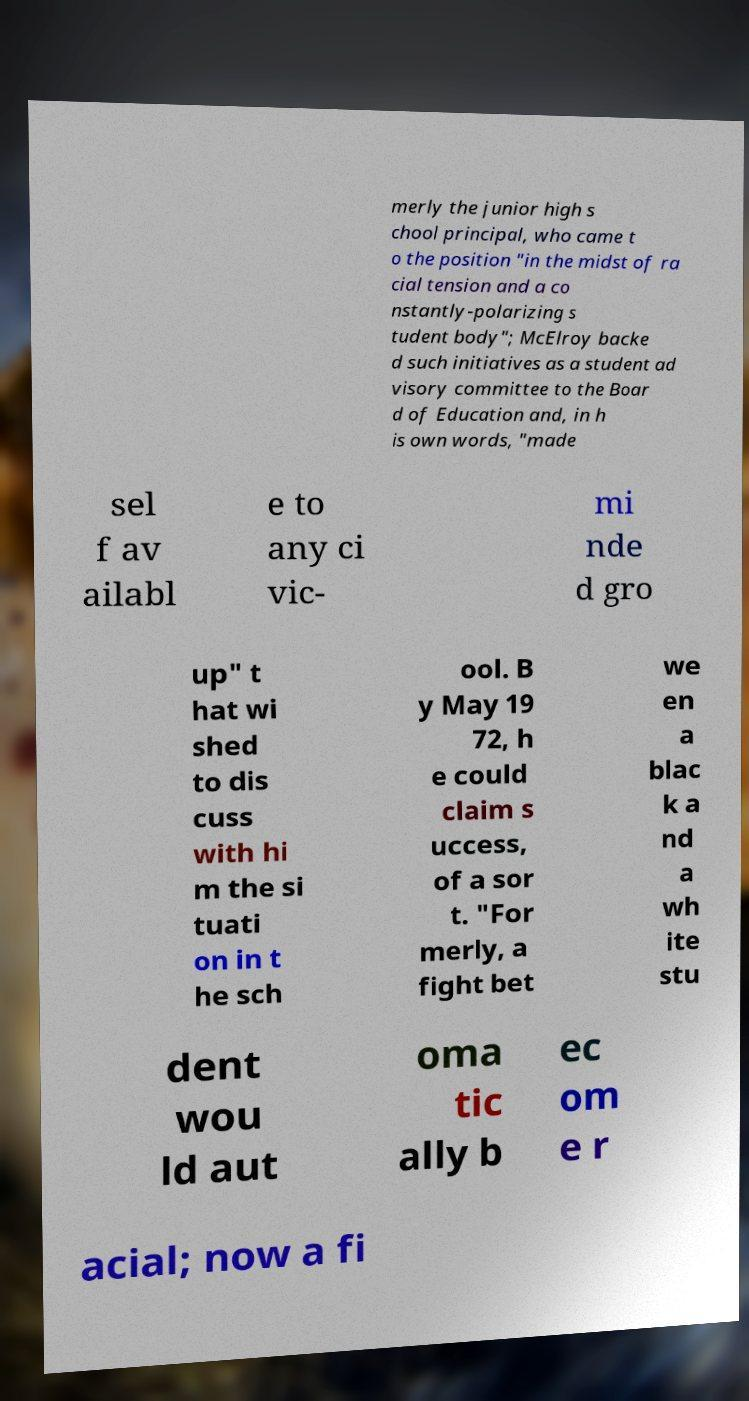For documentation purposes, I need the text within this image transcribed. Could you provide that? merly the junior high s chool principal, who came t o the position "in the midst of ra cial tension and a co nstantly-polarizing s tudent body"; McElroy backe d such initiatives as a student ad visory committee to the Boar d of Education and, in h is own words, "made sel f av ailabl e to any ci vic- mi nde d gro up" t hat wi shed to dis cuss with hi m the si tuati on in t he sch ool. B y May 19 72, h e could claim s uccess, of a sor t. "For merly, a fight bet we en a blac k a nd a wh ite stu dent wou ld aut oma tic ally b ec om e r acial; now a fi 